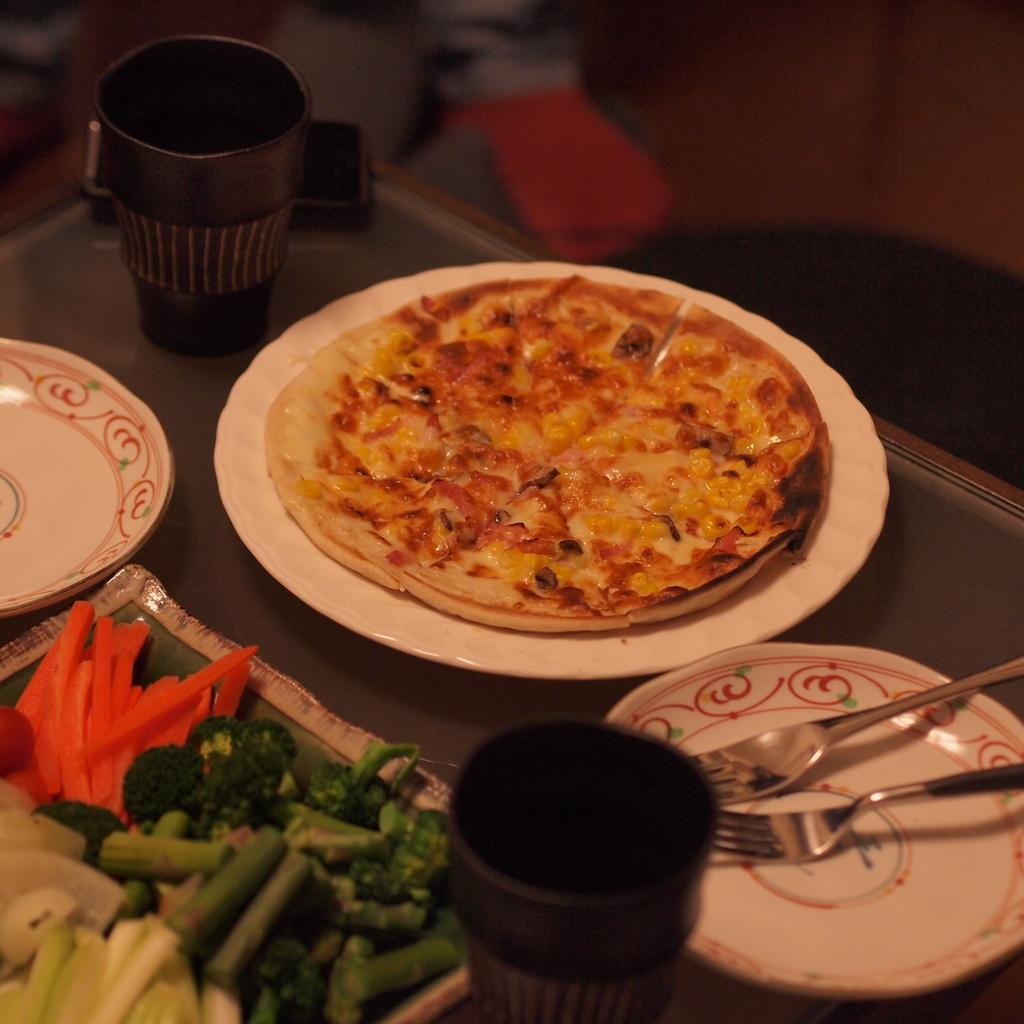What is on the plate that is visible in the image? There is a plate with food in the image. What type of food is on the plate? The provided facts do not specify the type of food on the plate. Besides the plate with food, what other items can be seen in the image? There are vegetable pieces in a tray, glasses, plates, and forks visible in the image. Where is the mobile located in the image? The mobile is on the table in the image. Can you tell me how many zephyrs are visible in the image? There is no mention of zephyrs in the image, as they are not a tangible object that can be seen. 